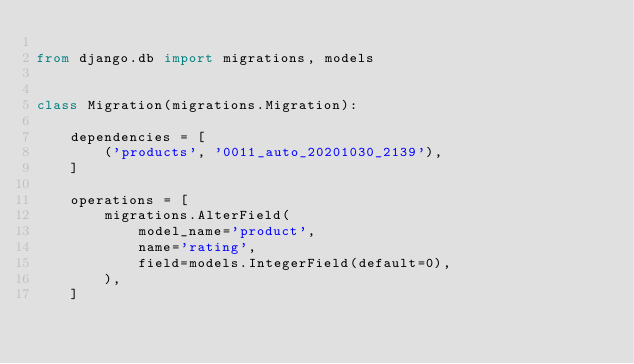<code> <loc_0><loc_0><loc_500><loc_500><_Python_>
from django.db import migrations, models


class Migration(migrations.Migration):

    dependencies = [
        ('products', '0011_auto_20201030_2139'),
    ]

    operations = [
        migrations.AlterField(
            model_name='product',
            name='rating',
            field=models.IntegerField(default=0),
        ),
    ]
</code> 